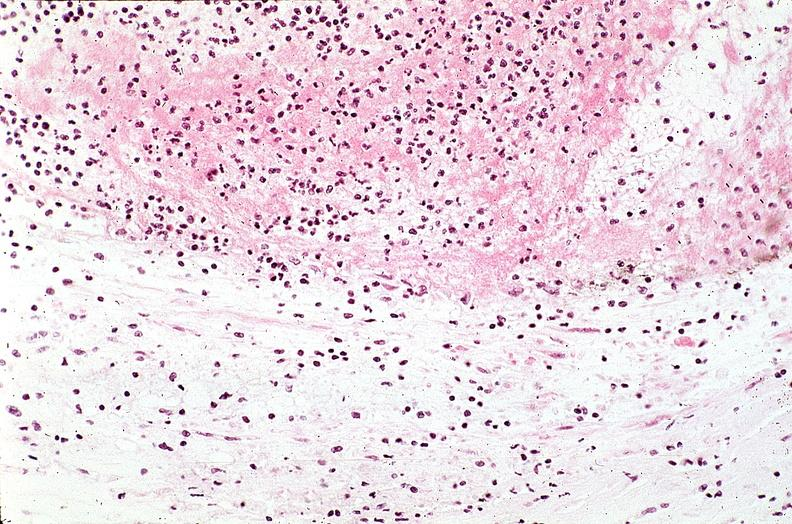s vasculature present?
Answer the question using a single word or phrase. Yes 